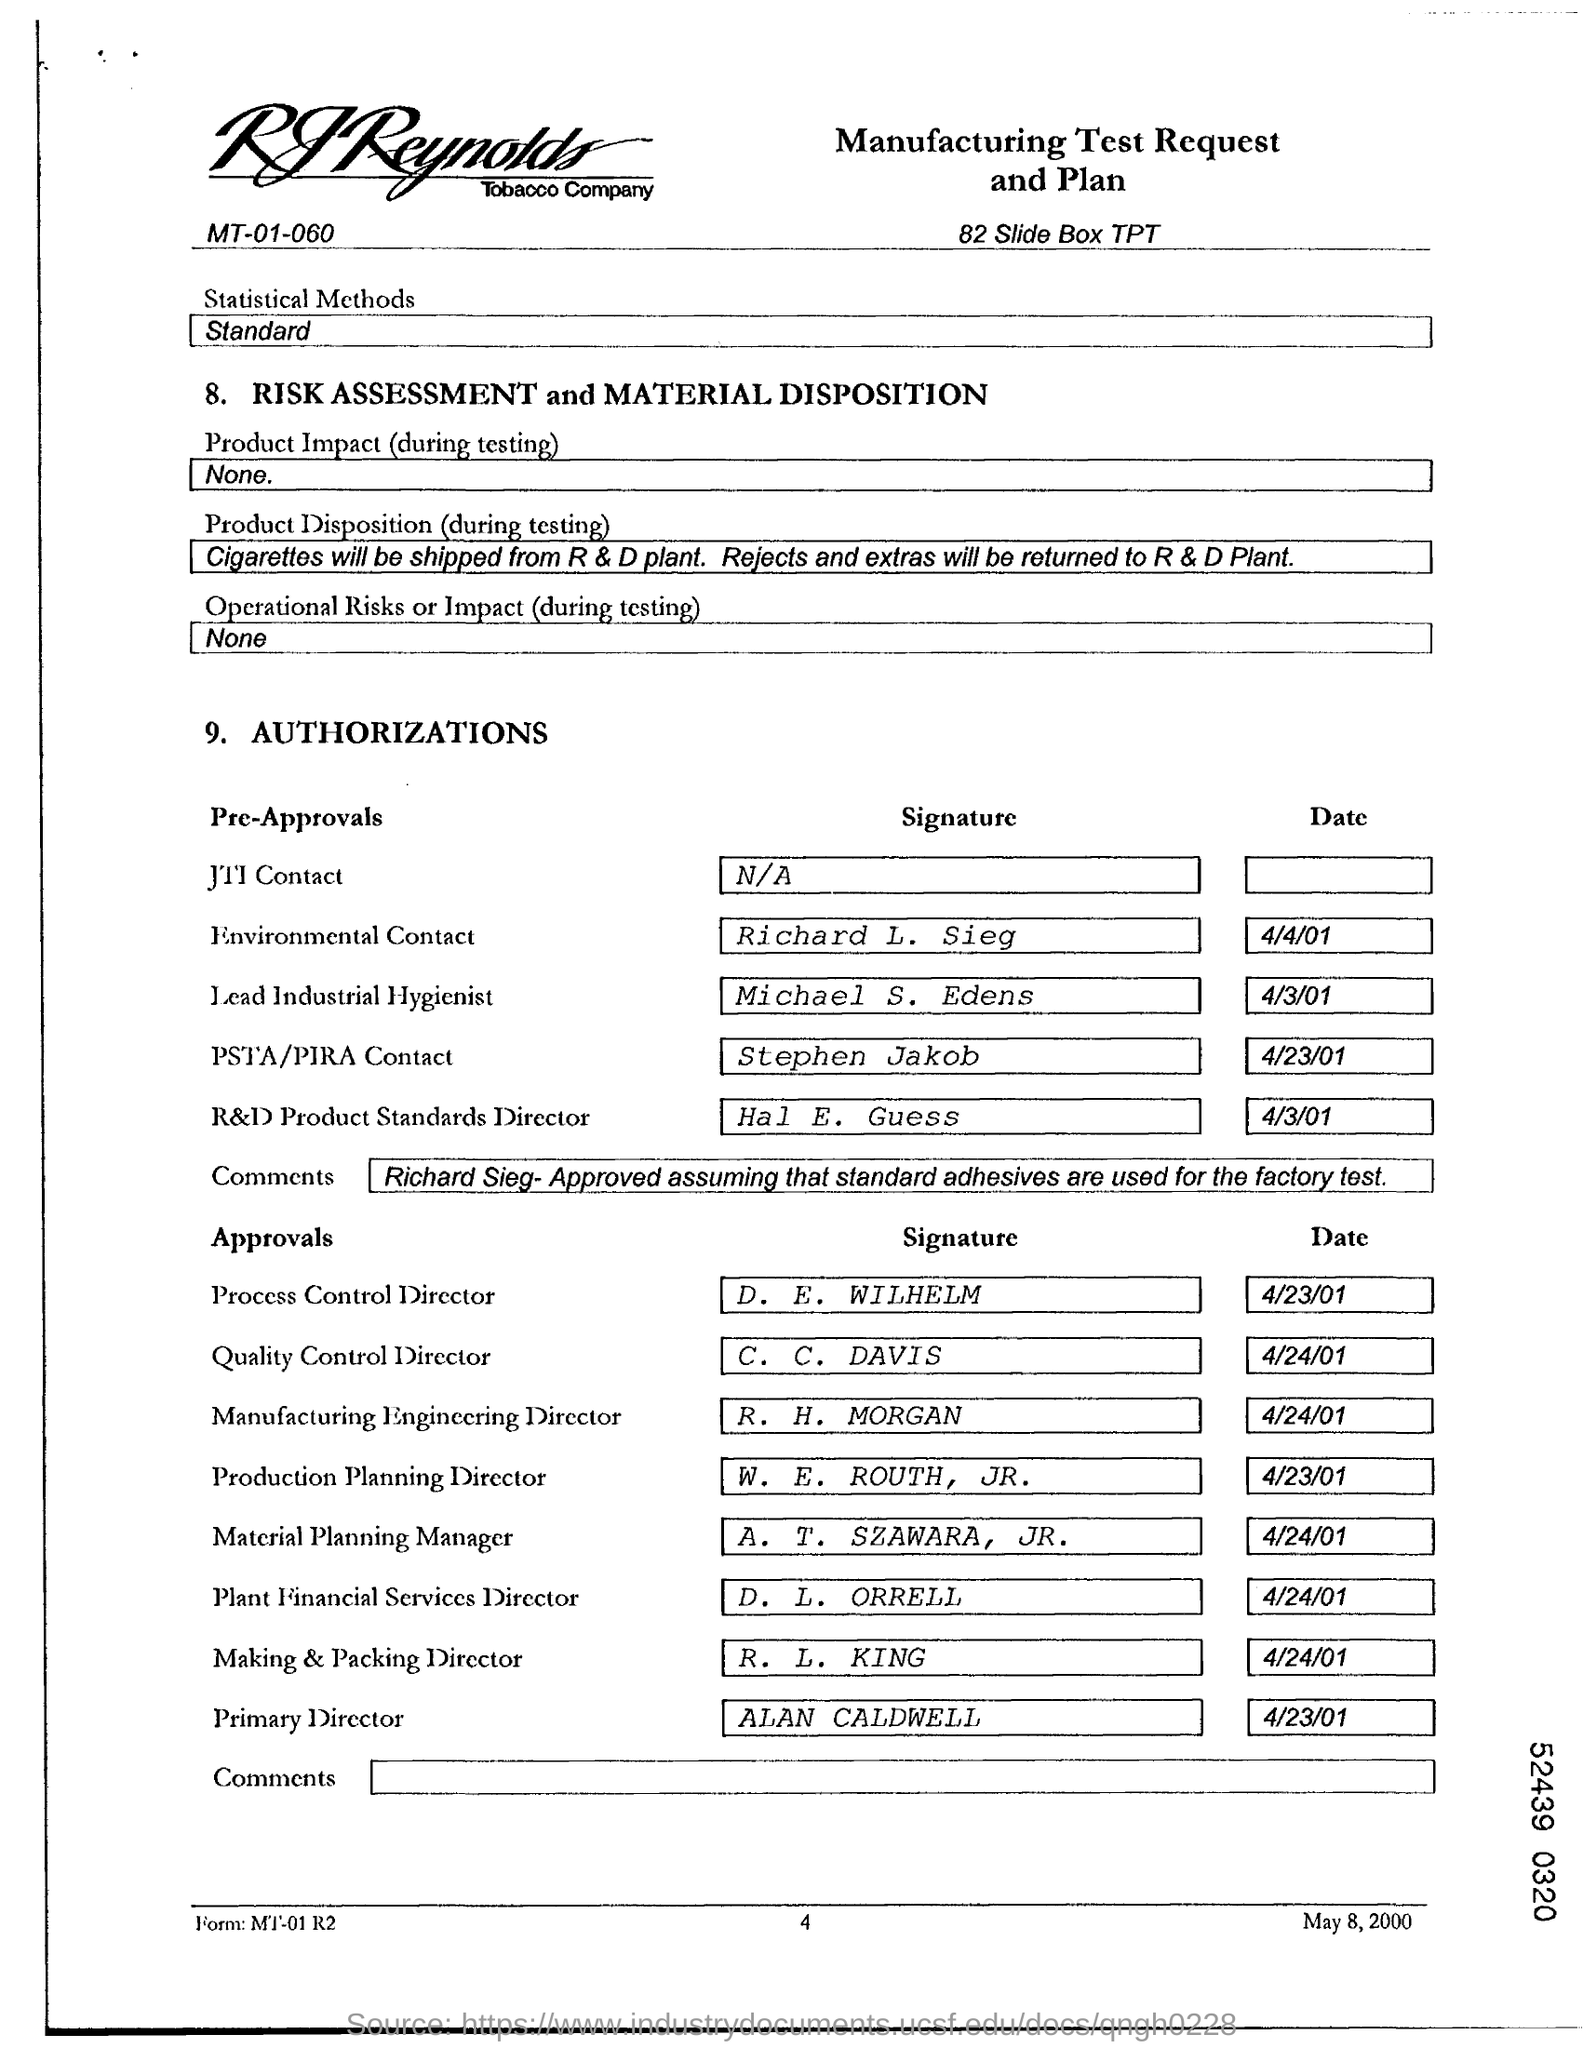Who is the "Process Control Director"?
Your response must be concise. D. E. WILHELM. What is the "Date" for "Alan Caldwell"?
Offer a terse response. 4/23/01. What is the "Date" for "Michael S.Edens"?
Your answer should be very brief. 4/3/01. Who is the "Quality Control Director"?
Your response must be concise. C. C.  DAVIS. 